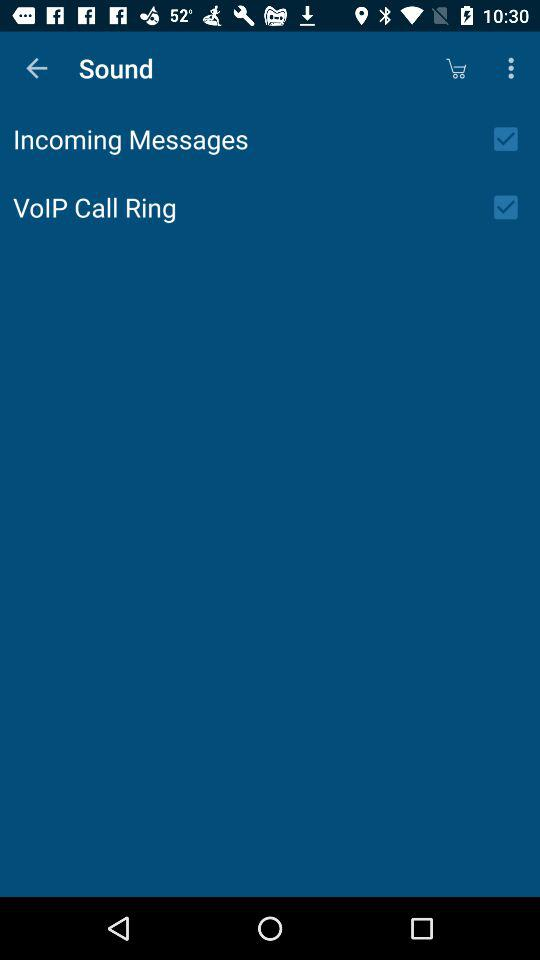What's the setting for incoming messages? The setting is on. 